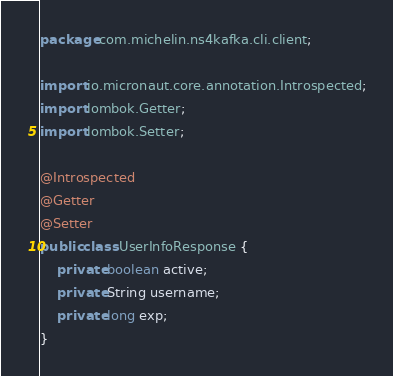<code> <loc_0><loc_0><loc_500><loc_500><_Java_>package com.michelin.ns4kafka.cli.client;

import io.micronaut.core.annotation.Introspected;
import lombok.Getter;
import lombok.Setter;

@Introspected
@Getter
@Setter
public class UserInfoResponse {
    private boolean active;
    private String username;
    private long exp;
}
</code> 